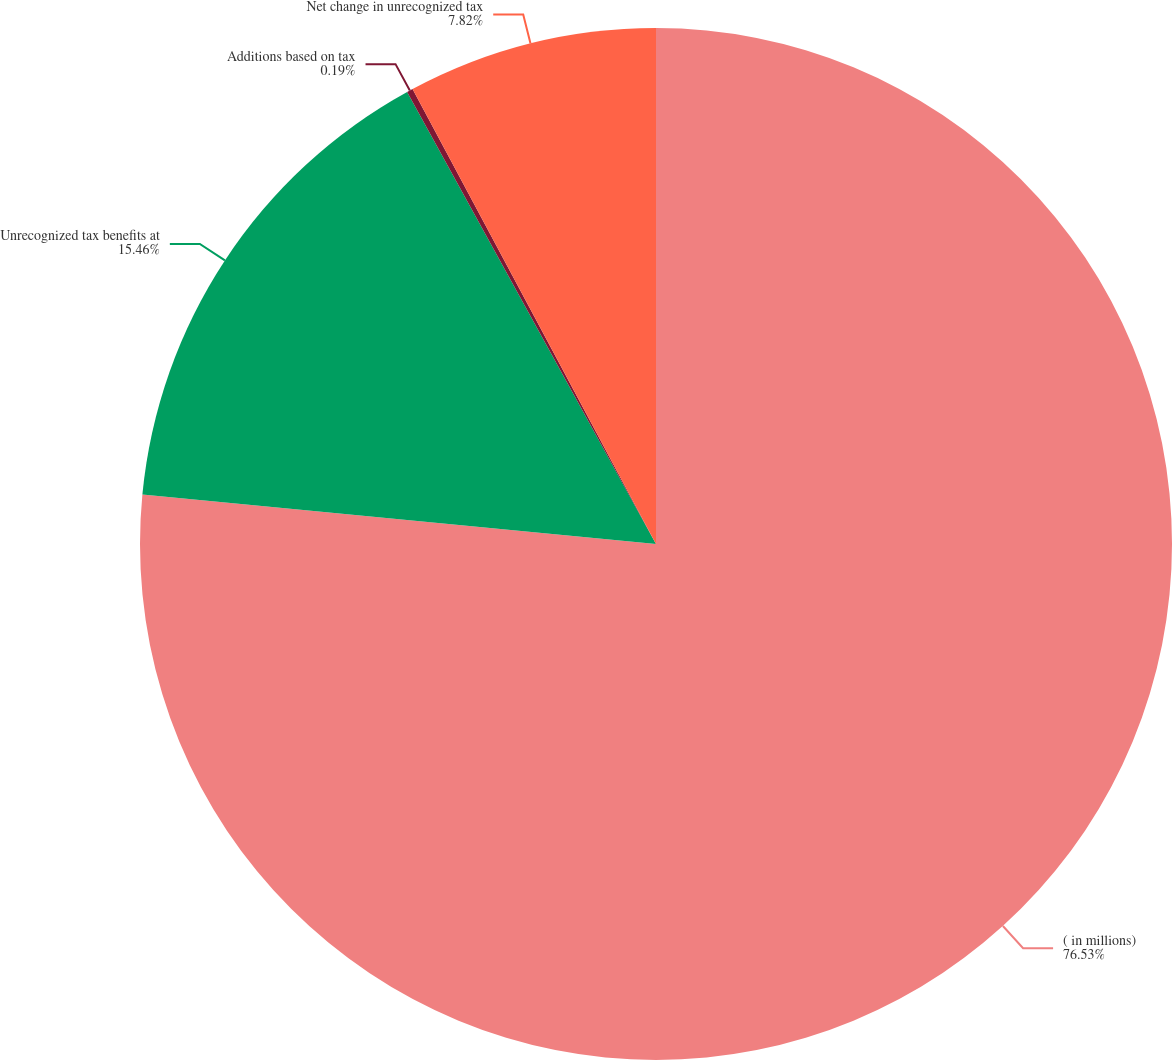<chart> <loc_0><loc_0><loc_500><loc_500><pie_chart><fcel>( in millions)<fcel>Unrecognized tax benefits at<fcel>Additions based on tax<fcel>Net change in unrecognized tax<nl><fcel>76.53%<fcel>15.46%<fcel>0.19%<fcel>7.82%<nl></chart> 